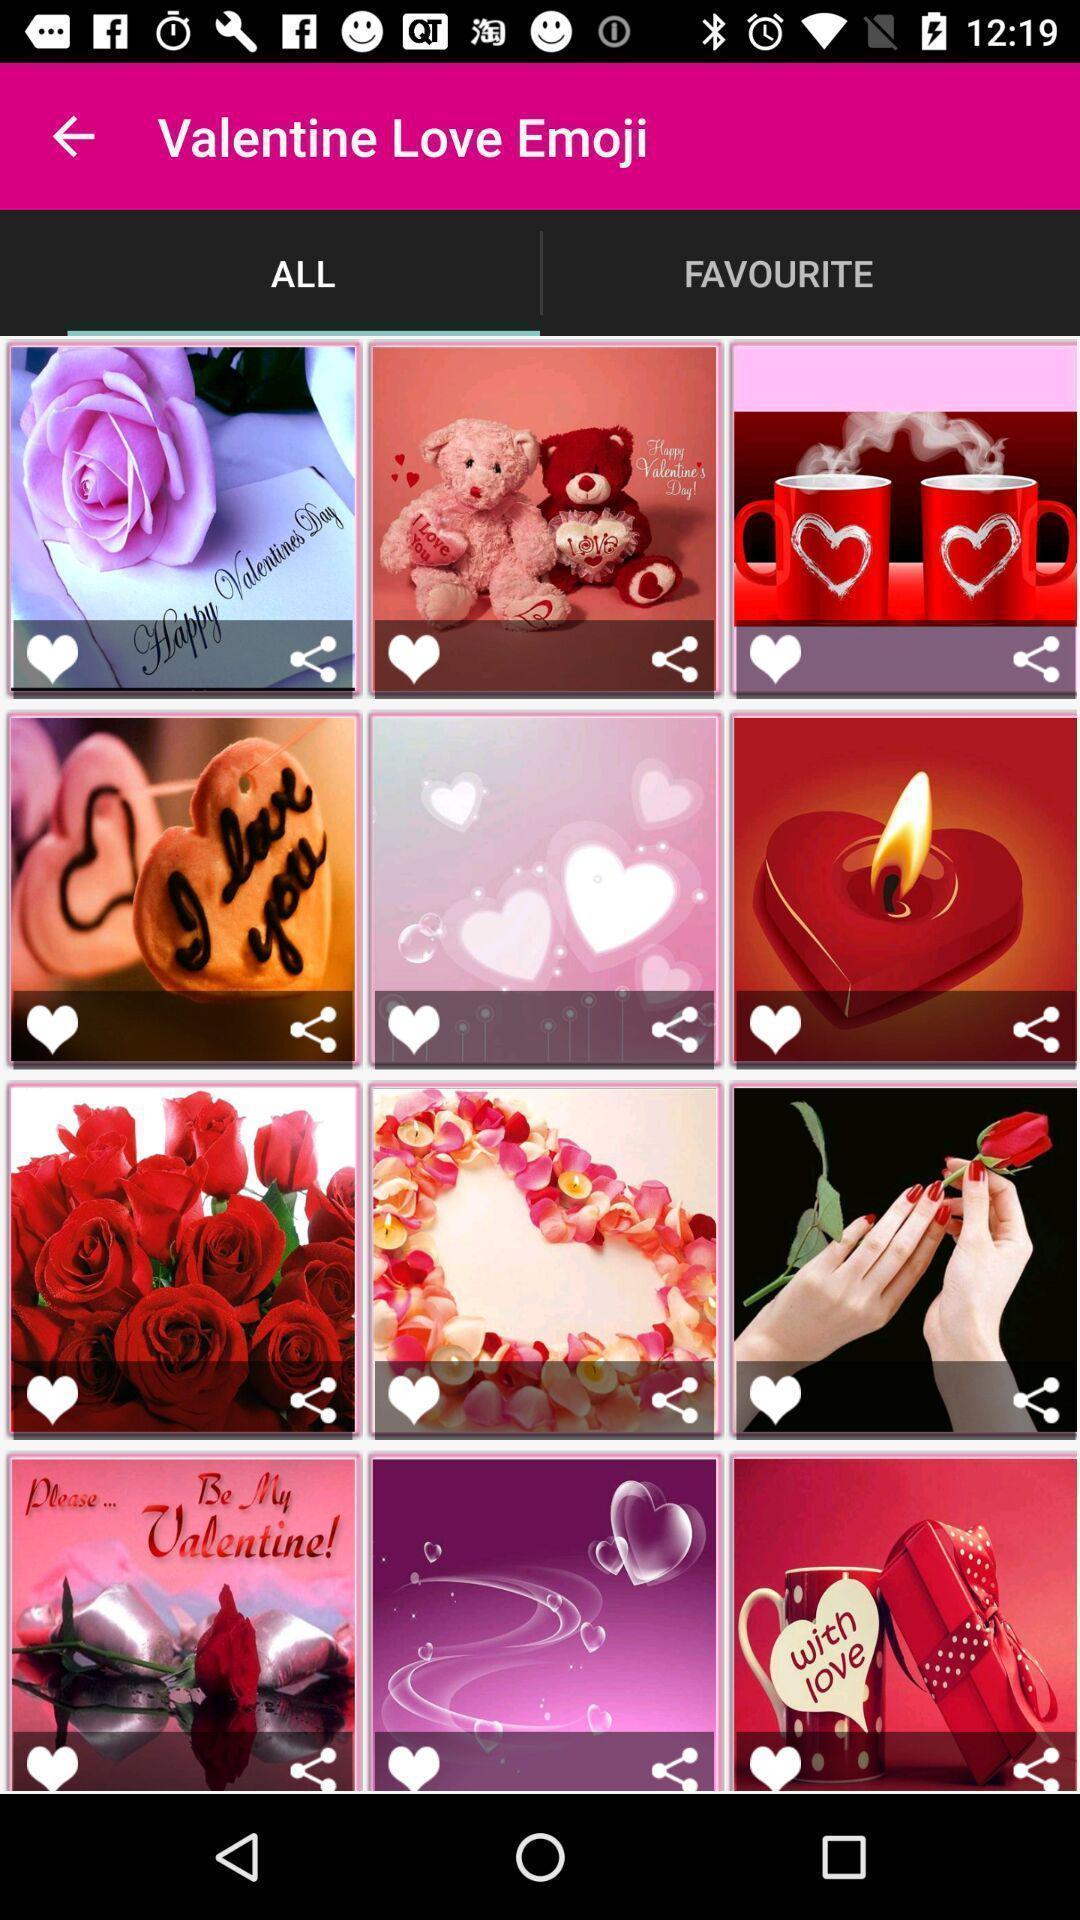Describe the key features of this screenshot. Various love emojis displayed. 